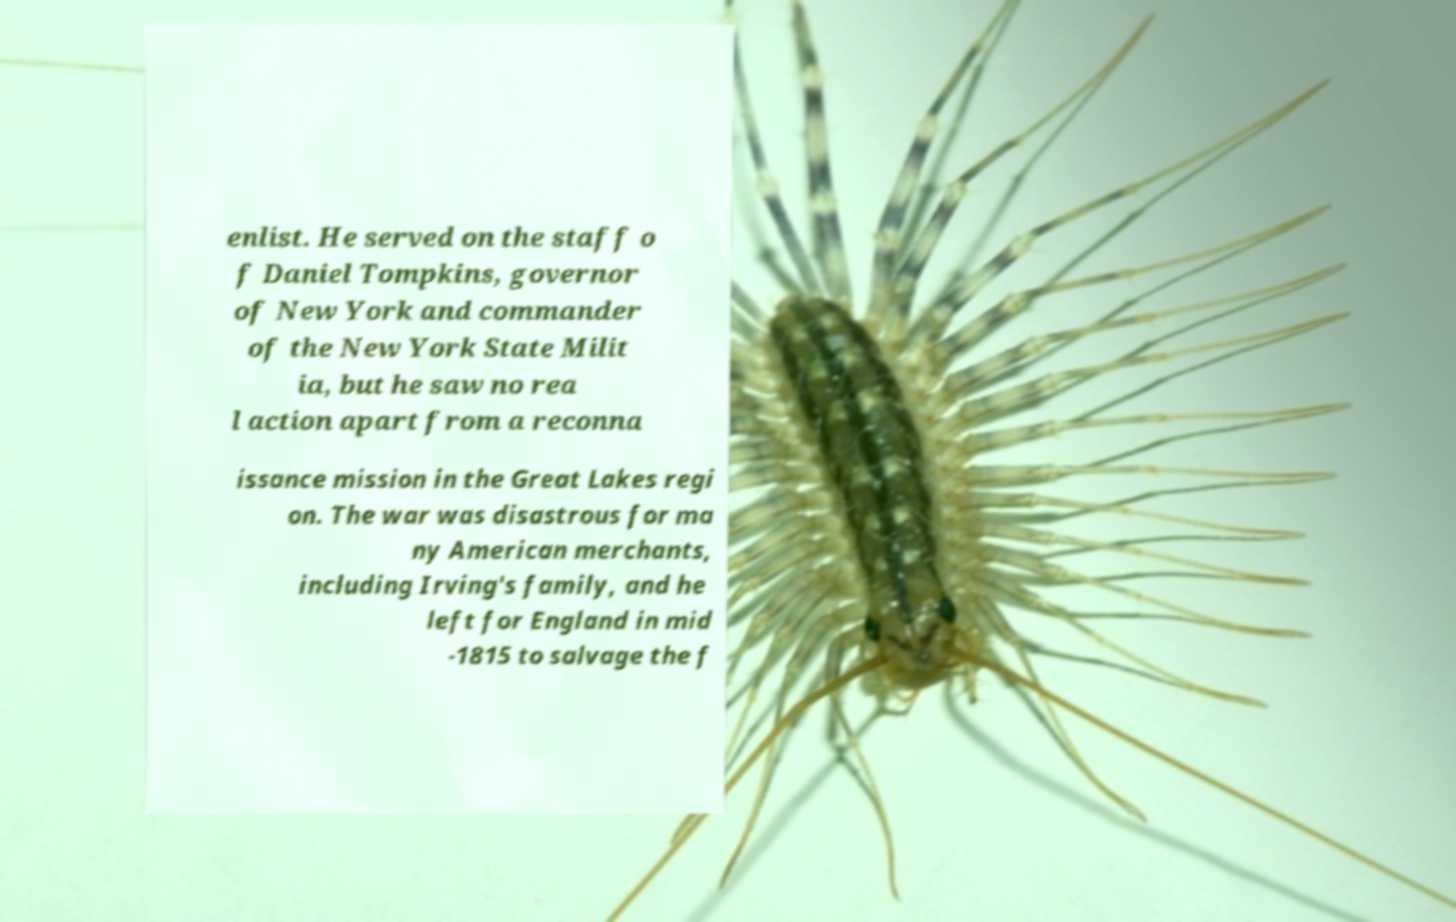What messages or text are displayed in this image? I need them in a readable, typed format. enlist. He served on the staff o f Daniel Tompkins, governor of New York and commander of the New York State Milit ia, but he saw no rea l action apart from a reconna issance mission in the Great Lakes regi on. The war was disastrous for ma ny American merchants, including Irving's family, and he left for England in mid -1815 to salvage the f 